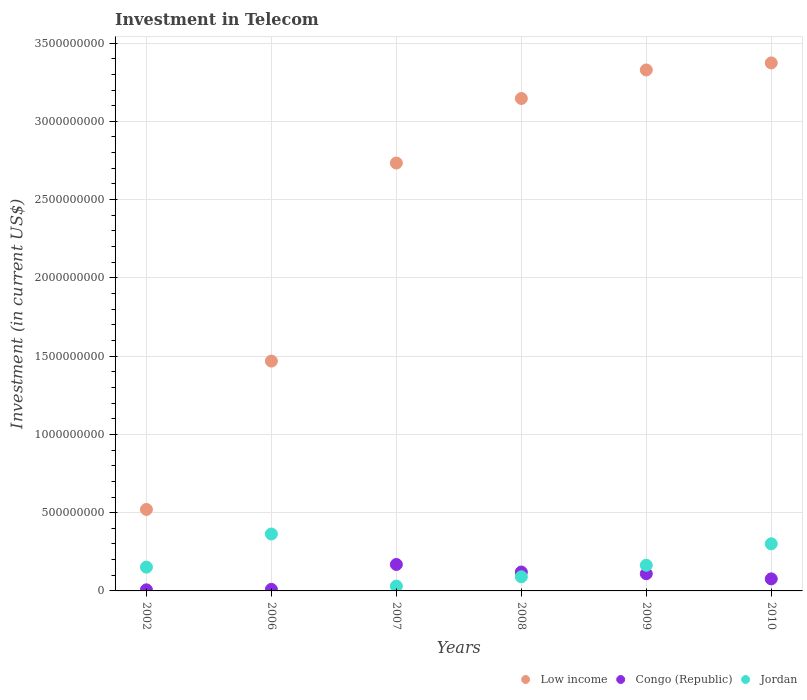How many different coloured dotlines are there?
Provide a succinct answer. 3. Is the number of dotlines equal to the number of legend labels?
Your answer should be compact. Yes. What is the amount invested in telecom in Jordan in 2006?
Ensure brevity in your answer.  3.64e+08. Across all years, what is the maximum amount invested in telecom in Low income?
Your answer should be very brief. 3.37e+09. Across all years, what is the minimum amount invested in telecom in Low income?
Your answer should be very brief. 5.20e+08. In which year was the amount invested in telecom in Low income maximum?
Provide a succinct answer. 2010. In which year was the amount invested in telecom in Low income minimum?
Provide a succinct answer. 2002. What is the total amount invested in telecom in Congo (Republic) in the graph?
Make the answer very short. 4.94e+08. What is the difference between the amount invested in telecom in Jordan in 2007 and that in 2010?
Provide a succinct answer. -2.70e+08. What is the difference between the amount invested in telecom in Jordan in 2002 and the amount invested in telecom in Congo (Republic) in 2008?
Offer a very short reply. 3.13e+07. What is the average amount invested in telecom in Jordan per year?
Your answer should be compact. 1.84e+08. In the year 2010, what is the difference between the amount invested in telecom in Low income and amount invested in telecom in Congo (Republic)?
Keep it short and to the point. 3.30e+09. What is the ratio of the amount invested in telecom in Congo (Republic) in 2006 to that in 2008?
Provide a succinct answer. 0.08. What is the difference between the highest and the second highest amount invested in telecom in Jordan?
Provide a succinct answer. 6.26e+07. What is the difference between the highest and the lowest amount invested in telecom in Low income?
Offer a terse response. 2.85e+09. Is the sum of the amount invested in telecom in Congo (Republic) in 2006 and 2010 greater than the maximum amount invested in telecom in Low income across all years?
Your answer should be very brief. No. Does the graph contain any zero values?
Offer a terse response. No. Does the graph contain grids?
Offer a very short reply. Yes. Where does the legend appear in the graph?
Your response must be concise. Bottom right. How many legend labels are there?
Your response must be concise. 3. What is the title of the graph?
Give a very brief answer. Investment in Telecom. Does "Kazakhstan" appear as one of the legend labels in the graph?
Your response must be concise. No. What is the label or title of the X-axis?
Offer a very short reply. Years. What is the label or title of the Y-axis?
Give a very brief answer. Investment (in current US$). What is the Investment (in current US$) in Low income in 2002?
Provide a short and direct response. 5.20e+08. What is the Investment (in current US$) in Congo (Republic) in 2002?
Provide a short and direct response. 7.00e+06. What is the Investment (in current US$) in Jordan in 2002?
Provide a short and direct response. 1.52e+08. What is the Investment (in current US$) of Low income in 2006?
Your answer should be very brief. 1.47e+09. What is the Investment (in current US$) of Jordan in 2006?
Offer a very short reply. 3.64e+08. What is the Investment (in current US$) of Low income in 2007?
Your answer should be compact. 2.73e+09. What is the Investment (in current US$) in Congo (Republic) in 2007?
Your answer should be very brief. 1.69e+08. What is the Investment (in current US$) of Jordan in 2007?
Make the answer very short. 3.07e+07. What is the Investment (in current US$) in Low income in 2008?
Offer a very short reply. 3.15e+09. What is the Investment (in current US$) in Congo (Republic) in 2008?
Offer a terse response. 1.21e+08. What is the Investment (in current US$) in Jordan in 2008?
Your response must be concise. 9.03e+07. What is the Investment (in current US$) of Low income in 2009?
Your answer should be compact. 3.33e+09. What is the Investment (in current US$) of Congo (Republic) in 2009?
Your answer should be very brief. 1.10e+08. What is the Investment (in current US$) of Jordan in 2009?
Make the answer very short. 1.64e+08. What is the Investment (in current US$) of Low income in 2010?
Ensure brevity in your answer.  3.37e+09. What is the Investment (in current US$) in Congo (Republic) in 2010?
Provide a succinct answer. 7.70e+07. What is the Investment (in current US$) of Jordan in 2010?
Your answer should be very brief. 3.01e+08. Across all years, what is the maximum Investment (in current US$) in Low income?
Make the answer very short. 3.37e+09. Across all years, what is the maximum Investment (in current US$) of Congo (Republic)?
Provide a short and direct response. 1.69e+08. Across all years, what is the maximum Investment (in current US$) of Jordan?
Your response must be concise. 3.64e+08. Across all years, what is the minimum Investment (in current US$) in Low income?
Your answer should be very brief. 5.20e+08. Across all years, what is the minimum Investment (in current US$) of Jordan?
Provide a short and direct response. 3.07e+07. What is the total Investment (in current US$) in Low income in the graph?
Provide a short and direct response. 1.46e+1. What is the total Investment (in current US$) of Congo (Republic) in the graph?
Keep it short and to the point. 4.94e+08. What is the total Investment (in current US$) in Jordan in the graph?
Your response must be concise. 1.10e+09. What is the difference between the Investment (in current US$) in Low income in 2002 and that in 2006?
Provide a short and direct response. -9.48e+08. What is the difference between the Investment (in current US$) in Jordan in 2002 and that in 2006?
Your answer should be very brief. -2.12e+08. What is the difference between the Investment (in current US$) of Low income in 2002 and that in 2007?
Offer a very short reply. -2.21e+09. What is the difference between the Investment (in current US$) in Congo (Republic) in 2002 and that in 2007?
Keep it short and to the point. -1.62e+08. What is the difference between the Investment (in current US$) in Jordan in 2002 and that in 2007?
Provide a short and direct response. 1.21e+08. What is the difference between the Investment (in current US$) of Low income in 2002 and that in 2008?
Make the answer very short. -2.63e+09. What is the difference between the Investment (in current US$) of Congo (Republic) in 2002 and that in 2008?
Provide a succinct answer. -1.14e+08. What is the difference between the Investment (in current US$) of Jordan in 2002 and that in 2008?
Offer a terse response. 6.17e+07. What is the difference between the Investment (in current US$) in Low income in 2002 and that in 2009?
Ensure brevity in your answer.  -2.81e+09. What is the difference between the Investment (in current US$) of Congo (Republic) in 2002 and that in 2009?
Provide a succinct answer. -1.03e+08. What is the difference between the Investment (in current US$) of Jordan in 2002 and that in 2009?
Offer a very short reply. -1.20e+07. What is the difference between the Investment (in current US$) in Low income in 2002 and that in 2010?
Give a very brief answer. -2.85e+09. What is the difference between the Investment (in current US$) in Congo (Republic) in 2002 and that in 2010?
Provide a short and direct response. -7.00e+07. What is the difference between the Investment (in current US$) of Jordan in 2002 and that in 2010?
Ensure brevity in your answer.  -1.49e+08. What is the difference between the Investment (in current US$) in Low income in 2006 and that in 2007?
Keep it short and to the point. -1.27e+09. What is the difference between the Investment (in current US$) in Congo (Republic) in 2006 and that in 2007?
Provide a short and direct response. -1.59e+08. What is the difference between the Investment (in current US$) of Jordan in 2006 and that in 2007?
Keep it short and to the point. 3.33e+08. What is the difference between the Investment (in current US$) of Low income in 2006 and that in 2008?
Keep it short and to the point. -1.68e+09. What is the difference between the Investment (in current US$) in Congo (Republic) in 2006 and that in 2008?
Your answer should be compact. -1.11e+08. What is the difference between the Investment (in current US$) in Jordan in 2006 and that in 2008?
Keep it short and to the point. 2.73e+08. What is the difference between the Investment (in current US$) of Low income in 2006 and that in 2009?
Ensure brevity in your answer.  -1.86e+09. What is the difference between the Investment (in current US$) of Congo (Republic) in 2006 and that in 2009?
Make the answer very short. -1.00e+08. What is the difference between the Investment (in current US$) of Jordan in 2006 and that in 2009?
Give a very brief answer. 2.00e+08. What is the difference between the Investment (in current US$) in Low income in 2006 and that in 2010?
Your answer should be very brief. -1.90e+09. What is the difference between the Investment (in current US$) in Congo (Republic) in 2006 and that in 2010?
Keep it short and to the point. -6.70e+07. What is the difference between the Investment (in current US$) of Jordan in 2006 and that in 2010?
Offer a terse response. 6.26e+07. What is the difference between the Investment (in current US$) in Low income in 2007 and that in 2008?
Your answer should be very brief. -4.12e+08. What is the difference between the Investment (in current US$) of Congo (Republic) in 2007 and that in 2008?
Ensure brevity in your answer.  4.83e+07. What is the difference between the Investment (in current US$) in Jordan in 2007 and that in 2008?
Offer a terse response. -5.96e+07. What is the difference between the Investment (in current US$) of Low income in 2007 and that in 2009?
Your answer should be very brief. -5.95e+08. What is the difference between the Investment (in current US$) of Congo (Republic) in 2007 and that in 2009?
Keep it short and to the point. 5.90e+07. What is the difference between the Investment (in current US$) in Jordan in 2007 and that in 2009?
Provide a short and direct response. -1.33e+08. What is the difference between the Investment (in current US$) in Low income in 2007 and that in 2010?
Keep it short and to the point. -6.40e+08. What is the difference between the Investment (in current US$) in Congo (Republic) in 2007 and that in 2010?
Give a very brief answer. 9.20e+07. What is the difference between the Investment (in current US$) in Jordan in 2007 and that in 2010?
Offer a terse response. -2.70e+08. What is the difference between the Investment (in current US$) of Low income in 2008 and that in 2009?
Make the answer very short. -1.82e+08. What is the difference between the Investment (in current US$) of Congo (Republic) in 2008 and that in 2009?
Ensure brevity in your answer.  1.07e+07. What is the difference between the Investment (in current US$) in Jordan in 2008 and that in 2009?
Your answer should be very brief. -7.37e+07. What is the difference between the Investment (in current US$) of Low income in 2008 and that in 2010?
Provide a succinct answer. -2.27e+08. What is the difference between the Investment (in current US$) in Congo (Republic) in 2008 and that in 2010?
Your answer should be compact. 4.37e+07. What is the difference between the Investment (in current US$) in Jordan in 2008 and that in 2010?
Ensure brevity in your answer.  -2.11e+08. What is the difference between the Investment (in current US$) of Low income in 2009 and that in 2010?
Make the answer very short. -4.50e+07. What is the difference between the Investment (in current US$) in Congo (Republic) in 2009 and that in 2010?
Offer a very short reply. 3.30e+07. What is the difference between the Investment (in current US$) in Jordan in 2009 and that in 2010?
Provide a succinct answer. -1.37e+08. What is the difference between the Investment (in current US$) in Low income in 2002 and the Investment (in current US$) in Congo (Republic) in 2006?
Provide a succinct answer. 5.10e+08. What is the difference between the Investment (in current US$) of Low income in 2002 and the Investment (in current US$) of Jordan in 2006?
Provide a short and direct response. 1.57e+08. What is the difference between the Investment (in current US$) in Congo (Republic) in 2002 and the Investment (in current US$) in Jordan in 2006?
Provide a succinct answer. -3.57e+08. What is the difference between the Investment (in current US$) in Low income in 2002 and the Investment (in current US$) in Congo (Republic) in 2007?
Provide a short and direct response. 3.51e+08. What is the difference between the Investment (in current US$) in Low income in 2002 and the Investment (in current US$) in Jordan in 2007?
Provide a short and direct response. 4.90e+08. What is the difference between the Investment (in current US$) in Congo (Republic) in 2002 and the Investment (in current US$) in Jordan in 2007?
Your response must be concise. -2.37e+07. What is the difference between the Investment (in current US$) of Low income in 2002 and the Investment (in current US$) of Congo (Republic) in 2008?
Provide a succinct answer. 4.00e+08. What is the difference between the Investment (in current US$) in Low income in 2002 and the Investment (in current US$) in Jordan in 2008?
Ensure brevity in your answer.  4.30e+08. What is the difference between the Investment (in current US$) of Congo (Republic) in 2002 and the Investment (in current US$) of Jordan in 2008?
Offer a terse response. -8.33e+07. What is the difference between the Investment (in current US$) of Low income in 2002 and the Investment (in current US$) of Congo (Republic) in 2009?
Your answer should be very brief. 4.10e+08. What is the difference between the Investment (in current US$) of Low income in 2002 and the Investment (in current US$) of Jordan in 2009?
Make the answer very short. 3.56e+08. What is the difference between the Investment (in current US$) in Congo (Republic) in 2002 and the Investment (in current US$) in Jordan in 2009?
Provide a succinct answer. -1.57e+08. What is the difference between the Investment (in current US$) in Low income in 2002 and the Investment (in current US$) in Congo (Republic) in 2010?
Make the answer very short. 4.43e+08. What is the difference between the Investment (in current US$) of Low income in 2002 and the Investment (in current US$) of Jordan in 2010?
Keep it short and to the point. 2.19e+08. What is the difference between the Investment (in current US$) of Congo (Republic) in 2002 and the Investment (in current US$) of Jordan in 2010?
Offer a terse response. -2.94e+08. What is the difference between the Investment (in current US$) in Low income in 2006 and the Investment (in current US$) in Congo (Republic) in 2007?
Offer a terse response. 1.30e+09. What is the difference between the Investment (in current US$) of Low income in 2006 and the Investment (in current US$) of Jordan in 2007?
Keep it short and to the point. 1.44e+09. What is the difference between the Investment (in current US$) of Congo (Republic) in 2006 and the Investment (in current US$) of Jordan in 2007?
Provide a short and direct response. -2.07e+07. What is the difference between the Investment (in current US$) of Low income in 2006 and the Investment (in current US$) of Congo (Republic) in 2008?
Your answer should be compact. 1.35e+09. What is the difference between the Investment (in current US$) in Low income in 2006 and the Investment (in current US$) in Jordan in 2008?
Your response must be concise. 1.38e+09. What is the difference between the Investment (in current US$) in Congo (Republic) in 2006 and the Investment (in current US$) in Jordan in 2008?
Offer a very short reply. -8.03e+07. What is the difference between the Investment (in current US$) in Low income in 2006 and the Investment (in current US$) in Congo (Republic) in 2009?
Ensure brevity in your answer.  1.36e+09. What is the difference between the Investment (in current US$) of Low income in 2006 and the Investment (in current US$) of Jordan in 2009?
Offer a terse response. 1.30e+09. What is the difference between the Investment (in current US$) in Congo (Republic) in 2006 and the Investment (in current US$) in Jordan in 2009?
Provide a succinct answer. -1.54e+08. What is the difference between the Investment (in current US$) of Low income in 2006 and the Investment (in current US$) of Congo (Republic) in 2010?
Provide a succinct answer. 1.39e+09. What is the difference between the Investment (in current US$) in Low income in 2006 and the Investment (in current US$) in Jordan in 2010?
Ensure brevity in your answer.  1.17e+09. What is the difference between the Investment (in current US$) in Congo (Republic) in 2006 and the Investment (in current US$) in Jordan in 2010?
Ensure brevity in your answer.  -2.91e+08. What is the difference between the Investment (in current US$) in Low income in 2007 and the Investment (in current US$) in Congo (Republic) in 2008?
Give a very brief answer. 2.61e+09. What is the difference between the Investment (in current US$) of Low income in 2007 and the Investment (in current US$) of Jordan in 2008?
Offer a very short reply. 2.64e+09. What is the difference between the Investment (in current US$) of Congo (Republic) in 2007 and the Investment (in current US$) of Jordan in 2008?
Provide a succinct answer. 7.87e+07. What is the difference between the Investment (in current US$) of Low income in 2007 and the Investment (in current US$) of Congo (Republic) in 2009?
Your answer should be very brief. 2.62e+09. What is the difference between the Investment (in current US$) of Low income in 2007 and the Investment (in current US$) of Jordan in 2009?
Your response must be concise. 2.57e+09. What is the difference between the Investment (in current US$) in Low income in 2007 and the Investment (in current US$) in Congo (Republic) in 2010?
Your response must be concise. 2.66e+09. What is the difference between the Investment (in current US$) of Low income in 2007 and the Investment (in current US$) of Jordan in 2010?
Make the answer very short. 2.43e+09. What is the difference between the Investment (in current US$) in Congo (Republic) in 2007 and the Investment (in current US$) in Jordan in 2010?
Ensure brevity in your answer.  -1.32e+08. What is the difference between the Investment (in current US$) of Low income in 2008 and the Investment (in current US$) of Congo (Republic) in 2009?
Provide a short and direct response. 3.04e+09. What is the difference between the Investment (in current US$) of Low income in 2008 and the Investment (in current US$) of Jordan in 2009?
Provide a succinct answer. 2.98e+09. What is the difference between the Investment (in current US$) of Congo (Republic) in 2008 and the Investment (in current US$) of Jordan in 2009?
Your response must be concise. -4.33e+07. What is the difference between the Investment (in current US$) in Low income in 2008 and the Investment (in current US$) in Congo (Republic) in 2010?
Provide a succinct answer. 3.07e+09. What is the difference between the Investment (in current US$) of Low income in 2008 and the Investment (in current US$) of Jordan in 2010?
Ensure brevity in your answer.  2.84e+09. What is the difference between the Investment (in current US$) in Congo (Republic) in 2008 and the Investment (in current US$) in Jordan in 2010?
Make the answer very short. -1.80e+08. What is the difference between the Investment (in current US$) in Low income in 2009 and the Investment (in current US$) in Congo (Republic) in 2010?
Your response must be concise. 3.25e+09. What is the difference between the Investment (in current US$) of Low income in 2009 and the Investment (in current US$) of Jordan in 2010?
Your answer should be compact. 3.03e+09. What is the difference between the Investment (in current US$) in Congo (Republic) in 2009 and the Investment (in current US$) in Jordan in 2010?
Provide a short and direct response. -1.91e+08. What is the average Investment (in current US$) of Low income per year?
Offer a very short reply. 2.43e+09. What is the average Investment (in current US$) of Congo (Republic) per year?
Offer a terse response. 8.23e+07. What is the average Investment (in current US$) of Jordan per year?
Keep it short and to the point. 1.84e+08. In the year 2002, what is the difference between the Investment (in current US$) of Low income and Investment (in current US$) of Congo (Republic)?
Provide a succinct answer. 5.13e+08. In the year 2002, what is the difference between the Investment (in current US$) of Low income and Investment (in current US$) of Jordan?
Your response must be concise. 3.68e+08. In the year 2002, what is the difference between the Investment (in current US$) in Congo (Republic) and Investment (in current US$) in Jordan?
Ensure brevity in your answer.  -1.45e+08. In the year 2006, what is the difference between the Investment (in current US$) of Low income and Investment (in current US$) of Congo (Republic)?
Your response must be concise. 1.46e+09. In the year 2006, what is the difference between the Investment (in current US$) in Low income and Investment (in current US$) in Jordan?
Provide a succinct answer. 1.10e+09. In the year 2006, what is the difference between the Investment (in current US$) in Congo (Republic) and Investment (in current US$) in Jordan?
Your response must be concise. -3.54e+08. In the year 2007, what is the difference between the Investment (in current US$) of Low income and Investment (in current US$) of Congo (Republic)?
Provide a short and direct response. 2.56e+09. In the year 2007, what is the difference between the Investment (in current US$) of Low income and Investment (in current US$) of Jordan?
Your answer should be compact. 2.70e+09. In the year 2007, what is the difference between the Investment (in current US$) in Congo (Republic) and Investment (in current US$) in Jordan?
Offer a very short reply. 1.38e+08. In the year 2008, what is the difference between the Investment (in current US$) in Low income and Investment (in current US$) in Congo (Republic)?
Offer a very short reply. 3.03e+09. In the year 2008, what is the difference between the Investment (in current US$) of Low income and Investment (in current US$) of Jordan?
Offer a terse response. 3.06e+09. In the year 2008, what is the difference between the Investment (in current US$) in Congo (Republic) and Investment (in current US$) in Jordan?
Give a very brief answer. 3.04e+07. In the year 2009, what is the difference between the Investment (in current US$) of Low income and Investment (in current US$) of Congo (Republic)?
Provide a short and direct response. 3.22e+09. In the year 2009, what is the difference between the Investment (in current US$) in Low income and Investment (in current US$) in Jordan?
Ensure brevity in your answer.  3.16e+09. In the year 2009, what is the difference between the Investment (in current US$) of Congo (Republic) and Investment (in current US$) of Jordan?
Keep it short and to the point. -5.40e+07. In the year 2010, what is the difference between the Investment (in current US$) of Low income and Investment (in current US$) of Congo (Republic)?
Ensure brevity in your answer.  3.30e+09. In the year 2010, what is the difference between the Investment (in current US$) in Low income and Investment (in current US$) in Jordan?
Offer a terse response. 3.07e+09. In the year 2010, what is the difference between the Investment (in current US$) of Congo (Republic) and Investment (in current US$) of Jordan?
Make the answer very short. -2.24e+08. What is the ratio of the Investment (in current US$) in Low income in 2002 to that in 2006?
Make the answer very short. 0.35. What is the ratio of the Investment (in current US$) of Jordan in 2002 to that in 2006?
Your answer should be very brief. 0.42. What is the ratio of the Investment (in current US$) in Low income in 2002 to that in 2007?
Your response must be concise. 0.19. What is the ratio of the Investment (in current US$) in Congo (Republic) in 2002 to that in 2007?
Give a very brief answer. 0.04. What is the ratio of the Investment (in current US$) in Jordan in 2002 to that in 2007?
Provide a short and direct response. 4.95. What is the ratio of the Investment (in current US$) of Low income in 2002 to that in 2008?
Your answer should be very brief. 0.17. What is the ratio of the Investment (in current US$) in Congo (Republic) in 2002 to that in 2008?
Keep it short and to the point. 0.06. What is the ratio of the Investment (in current US$) in Jordan in 2002 to that in 2008?
Your answer should be very brief. 1.68. What is the ratio of the Investment (in current US$) of Low income in 2002 to that in 2009?
Keep it short and to the point. 0.16. What is the ratio of the Investment (in current US$) in Congo (Republic) in 2002 to that in 2009?
Make the answer very short. 0.06. What is the ratio of the Investment (in current US$) of Jordan in 2002 to that in 2009?
Offer a very short reply. 0.93. What is the ratio of the Investment (in current US$) in Low income in 2002 to that in 2010?
Ensure brevity in your answer.  0.15. What is the ratio of the Investment (in current US$) of Congo (Republic) in 2002 to that in 2010?
Make the answer very short. 0.09. What is the ratio of the Investment (in current US$) in Jordan in 2002 to that in 2010?
Ensure brevity in your answer.  0.51. What is the ratio of the Investment (in current US$) in Low income in 2006 to that in 2007?
Offer a very short reply. 0.54. What is the ratio of the Investment (in current US$) in Congo (Republic) in 2006 to that in 2007?
Provide a succinct answer. 0.06. What is the ratio of the Investment (in current US$) in Jordan in 2006 to that in 2007?
Your response must be concise. 11.84. What is the ratio of the Investment (in current US$) in Low income in 2006 to that in 2008?
Offer a very short reply. 0.47. What is the ratio of the Investment (in current US$) in Congo (Republic) in 2006 to that in 2008?
Keep it short and to the point. 0.08. What is the ratio of the Investment (in current US$) of Jordan in 2006 to that in 2008?
Offer a very short reply. 4.03. What is the ratio of the Investment (in current US$) of Low income in 2006 to that in 2009?
Keep it short and to the point. 0.44. What is the ratio of the Investment (in current US$) of Congo (Republic) in 2006 to that in 2009?
Your answer should be compact. 0.09. What is the ratio of the Investment (in current US$) of Jordan in 2006 to that in 2009?
Give a very brief answer. 2.22. What is the ratio of the Investment (in current US$) in Low income in 2006 to that in 2010?
Give a very brief answer. 0.44. What is the ratio of the Investment (in current US$) in Congo (Republic) in 2006 to that in 2010?
Provide a succinct answer. 0.13. What is the ratio of the Investment (in current US$) of Jordan in 2006 to that in 2010?
Your answer should be very brief. 1.21. What is the ratio of the Investment (in current US$) in Low income in 2007 to that in 2008?
Keep it short and to the point. 0.87. What is the ratio of the Investment (in current US$) of Congo (Republic) in 2007 to that in 2008?
Your answer should be very brief. 1.4. What is the ratio of the Investment (in current US$) of Jordan in 2007 to that in 2008?
Your response must be concise. 0.34. What is the ratio of the Investment (in current US$) in Low income in 2007 to that in 2009?
Provide a short and direct response. 0.82. What is the ratio of the Investment (in current US$) of Congo (Republic) in 2007 to that in 2009?
Give a very brief answer. 1.54. What is the ratio of the Investment (in current US$) in Jordan in 2007 to that in 2009?
Provide a short and direct response. 0.19. What is the ratio of the Investment (in current US$) in Low income in 2007 to that in 2010?
Offer a terse response. 0.81. What is the ratio of the Investment (in current US$) in Congo (Republic) in 2007 to that in 2010?
Offer a very short reply. 2.19. What is the ratio of the Investment (in current US$) in Jordan in 2007 to that in 2010?
Make the answer very short. 0.1. What is the ratio of the Investment (in current US$) in Low income in 2008 to that in 2009?
Provide a succinct answer. 0.95. What is the ratio of the Investment (in current US$) of Congo (Republic) in 2008 to that in 2009?
Offer a terse response. 1.1. What is the ratio of the Investment (in current US$) in Jordan in 2008 to that in 2009?
Provide a succinct answer. 0.55. What is the ratio of the Investment (in current US$) in Low income in 2008 to that in 2010?
Provide a succinct answer. 0.93. What is the ratio of the Investment (in current US$) in Congo (Republic) in 2008 to that in 2010?
Your response must be concise. 1.57. What is the ratio of the Investment (in current US$) of Jordan in 2008 to that in 2010?
Provide a short and direct response. 0.3. What is the ratio of the Investment (in current US$) in Low income in 2009 to that in 2010?
Your answer should be very brief. 0.99. What is the ratio of the Investment (in current US$) of Congo (Republic) in 2009 to that in 2010?
Offer a terse response. 1.43. What is the ratio of the Investment (in current US$) of Jordan in 2009 to that in 2010?
Give a very brief answer. 0.54. What is the difference between the highest and the second highest Investment (in current US$) of Low income?
Provide a short and direct response. 4.50e+07. What is the difference between the highest and the second highest Investment (in current US$) of Congo (Republic)?
Your response must be concise. 4.83e+07. What is the difference between the highest and the second highest Investment (in current US$) in Jordan?
Give a very brief answer. 6.26e+07. What is the difference between the highest and the lowest Investment (in current US$) of Low income?
Ensure brevity in your answer.  2.85e+09. What is the difference between the highest and the lowest Investment (in current US$) in Congo (Republic)?
Ensure brevity in your answer.  1.62e+08. What is the difference between the highest and the lowest Investment (in current US$) in Jordan?
Ensure brevity in your answer.  3.33e+08. 